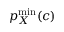Convert formula to latex. <formula><loc_0><loc_0><loc_500><loc_500>p _ { X } ^ { \min } ( c )</formula> 